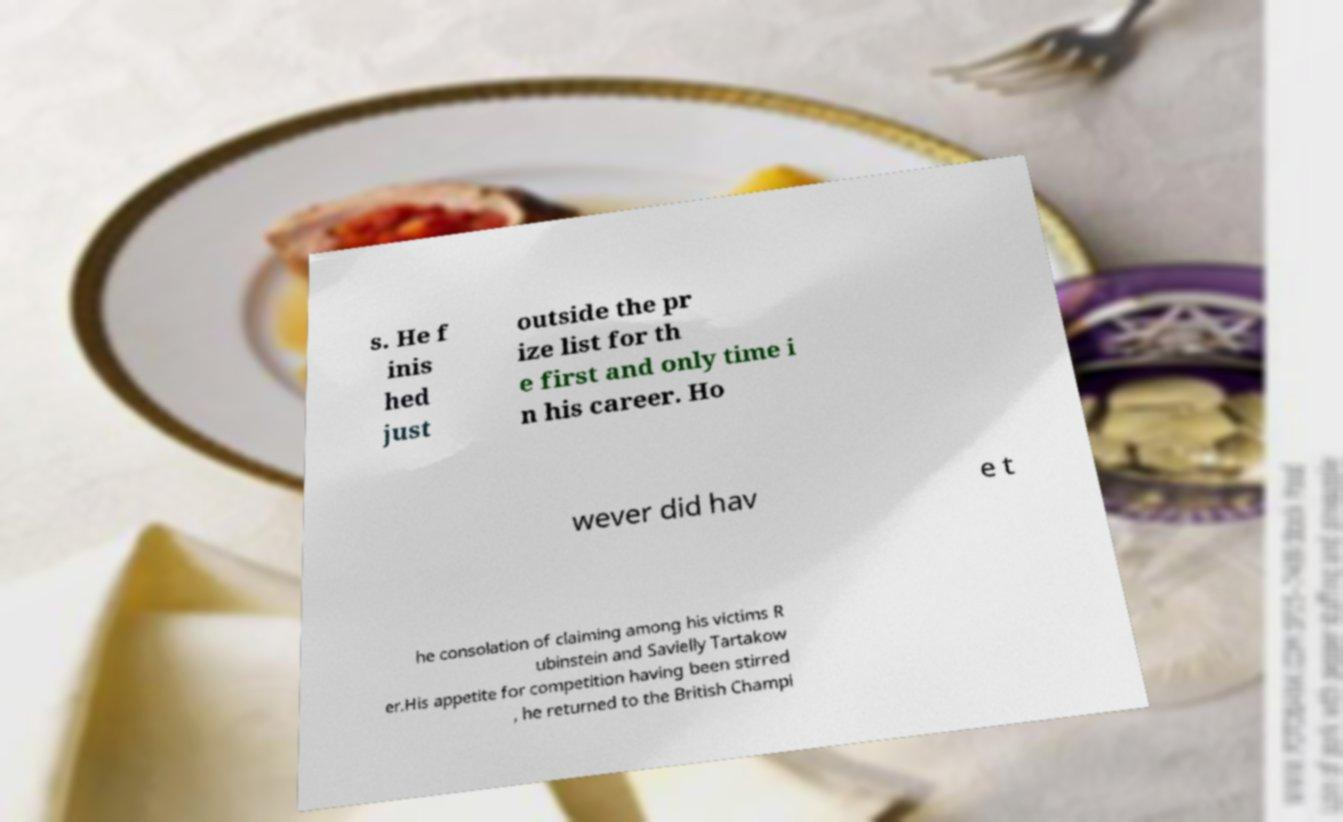Can you read and provide the text displayed in the image?This photo seems to have some interesting text. Can you extract and type it out for me? s. He f inis hed just outside the pr ize list for th e first and only time i n his career. Ho wever did hav e t he consolation of claiming among his victims R ubinstein and Savielly Tartakow er.His appetite for competition having been stirred , he returned to the British Champi 